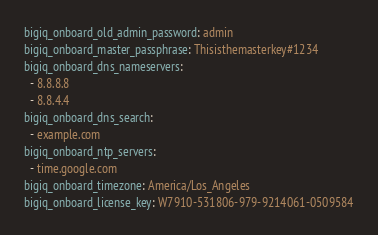Convert code to text. <code><loc_0><loc_0><loc_500><loc_500><_YAML_>bigiq_onboard_old_admin_password: admin
bigiq_onboard_master_passphrase: Thisisthemasterkey#1234
bigiq_onboard_dns_nameservers:
  - 8.8.8.8
  - 8.8.4.4
bigiq_onboard_dns_search:
  - example.com
bigiq_onboard_ntp_servers:
  - time.google.com
bigiq_onboard_timezone: America/Los_Angeles
bigiq_onboard_license_key: W7910-531806-979-9214061-0509584</code> 